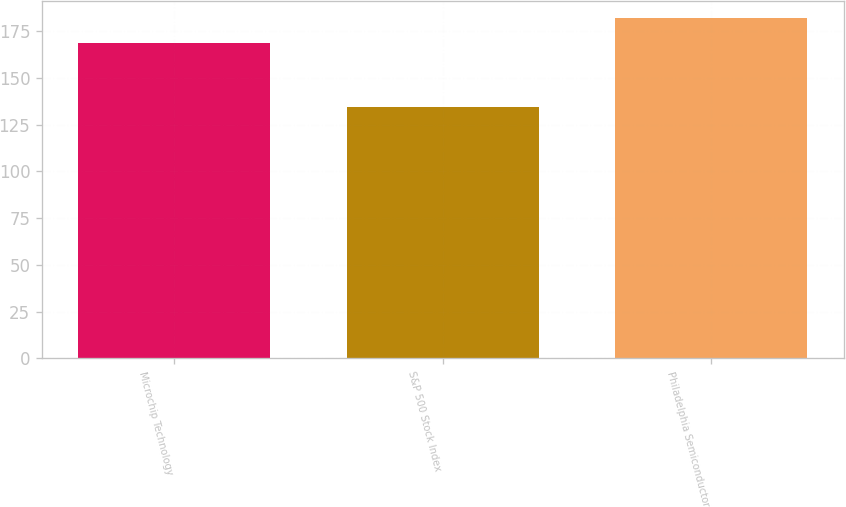Convert chart to OTSL. <chart><loc_0><loc_0><loc_500><loc_500><bar_chart><fcel>Microchip Technology<fcel>S&P 500 Stock Index<fcel>Philadelphia Semiconductor<nl><fcel>168.33<fcel>134.45<fcel>182.14<nl></chart> 